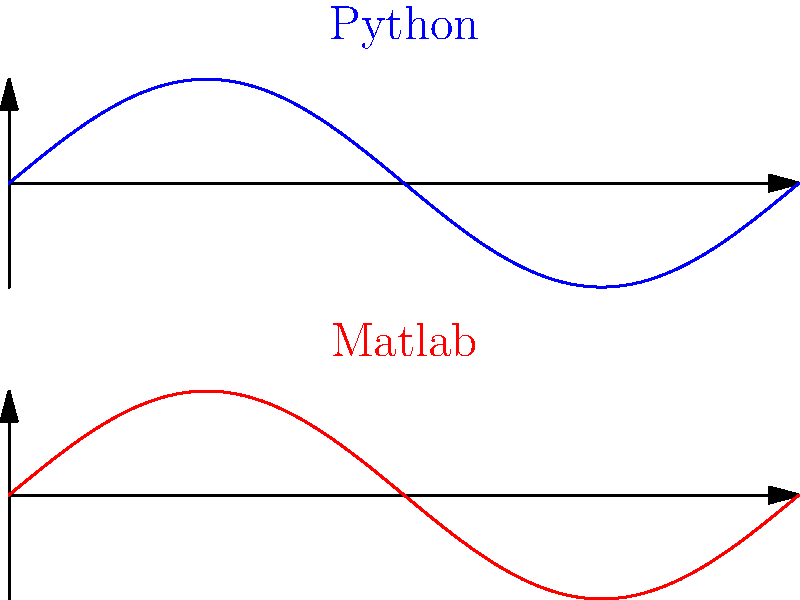Which of the following statements correctly describes the difference between plotting sine waves using Python's matplotlib and Matlab's plot function, as shown in the diagram?

A) Python's plot has a blue line, while Matlab's plot has a red line
B) Python's plot uses different axis limits than Matlab's plot
C) Python's plot shows a cosine wave, while Matlab's plot shows a sine wave
D) Python's plot has more data points than Matlab's plot Let's analyze the diagram step-by-step:

1. The diagram shows two plots of sine waves, one labeled "Python" and the other labeled "Matlab".

2. Both plots show sine waves with the same shape and period, covering the range from 0 to 2π on the x-axis.

3. The upper plot (Python) is drawn in blue, while the lower plot (Matlab) is drawn in red.

4. The axis limits and scales appear to be identical for both plots.

5. Both plots show the same number of data points and the same level of smoothness in the curve.

6. The only noticeable difference between the two plots is the color of the line used to represent the sine wave.

Therefore, the correct statement is that Python's plot has a blue line, while Matlab's plot has a red line. This difference in color is purely a visual distinction and does not reflect any fundamental difference in the plotting capabilities or output of the two systems.
Answer: A) Python's plot has a blue line, while Matlab's plot has a red line 